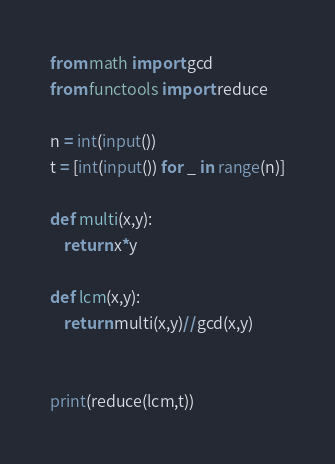Convert code to text. <code><loc_0><loc_0><loc_500><loc_500><_Python_>from math import gcd
from functools import reduce

n = int(input())
t = [int(input()) for _ in range(n)]

def multi(x,y):
	return x*y

def lcm(x,y):
	return multi(x,y)//gcd(x,y)


print(reduce(lcm,t))
</code> 